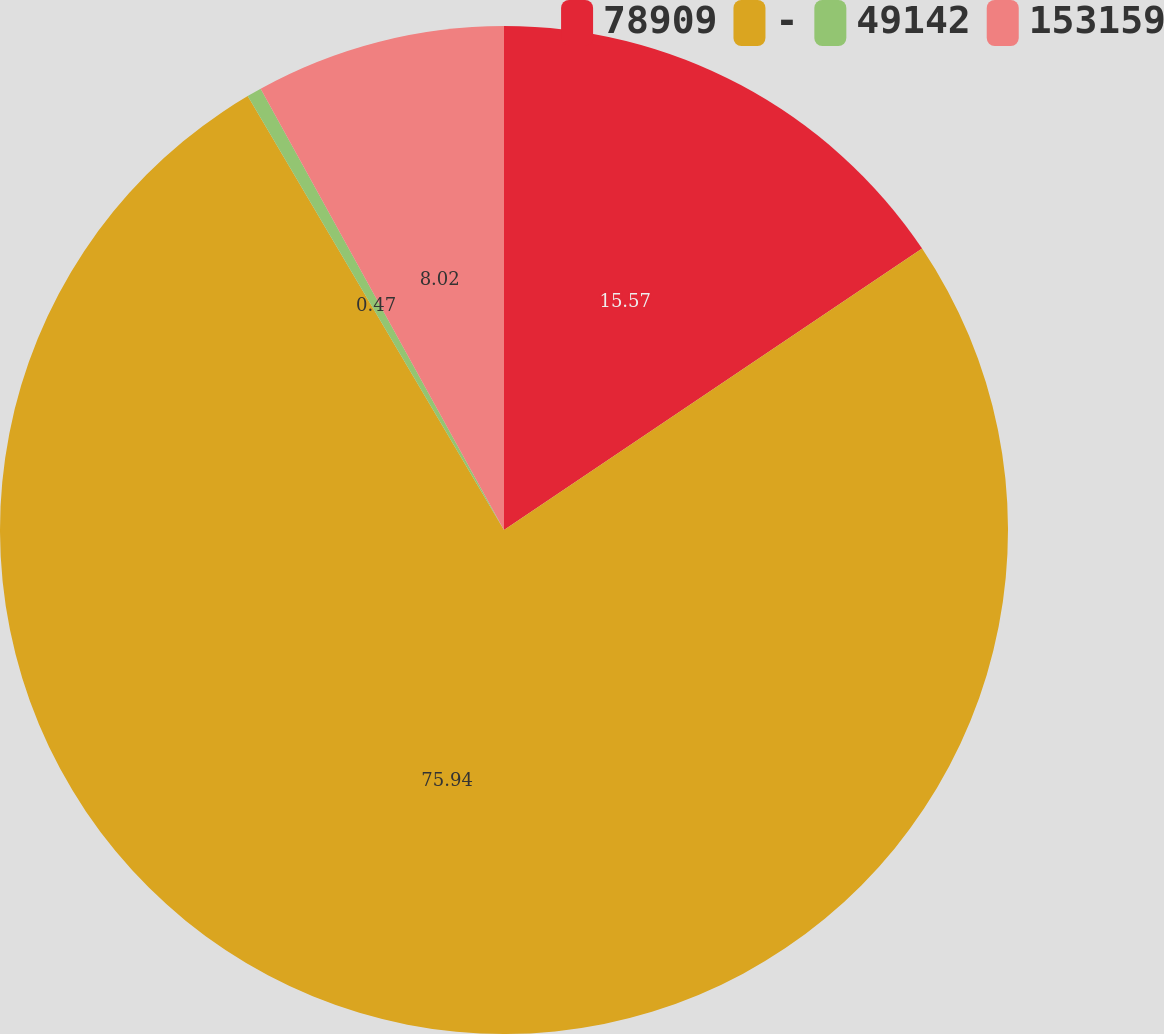Convert chart to OTSL. <chart><loc_0><loc_0><loc_500><loc_500><pie_chart><fcel>78909<fcel>-<fcel>49142<fcel>153159<nl><fcel>15.57%<fcel>75.94%<fcel>0.47%<fcel>8.02%<nl></chart> 